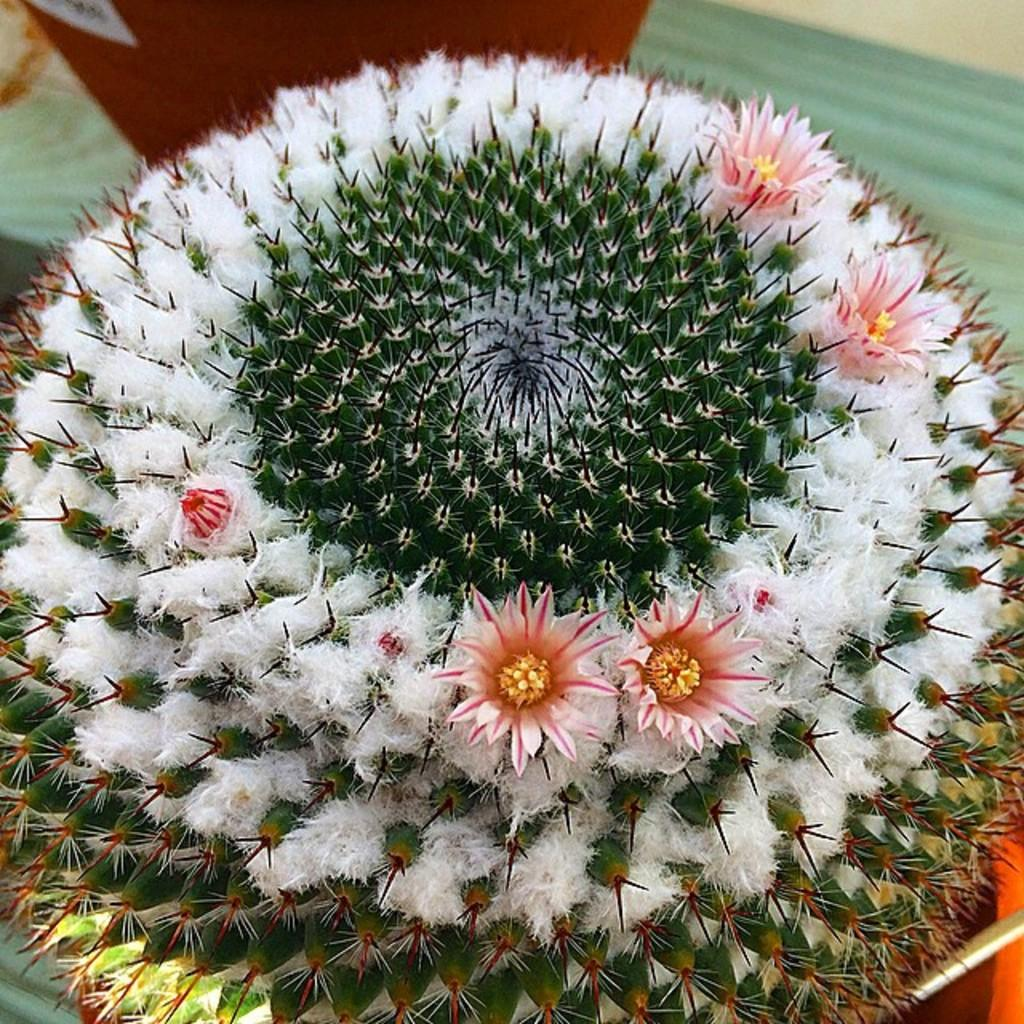What type of living organism is in the picture? There is a plant in the picture. What features can be observed on the plant? The plant has flowers and thorns. What type of mitten can be seen on the plant in the image? There is no mitten present on the plant in the image. What shape are the lizards in the image? There are no lizards present in the image. 